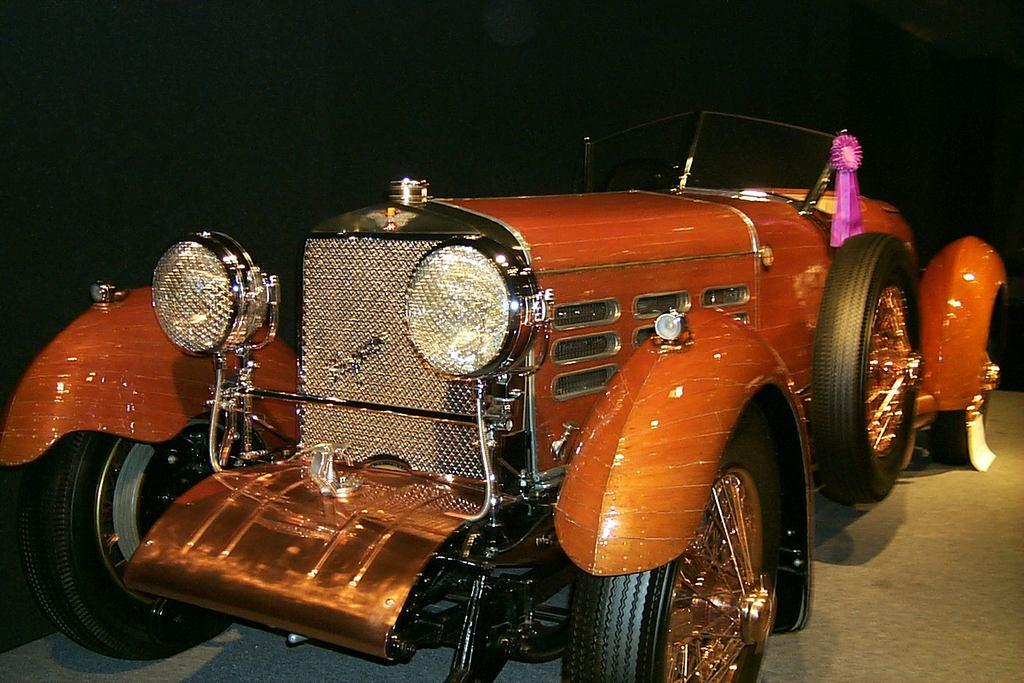What is the main subject in the center of the image? There is a vehicle in the center of the image. What is the setting of the image? The image features a road at the bottom. What type of harmony is being played in the background of the image? There is no music or sound present in the image, so it is not possible to determine if any harmony is being played. 